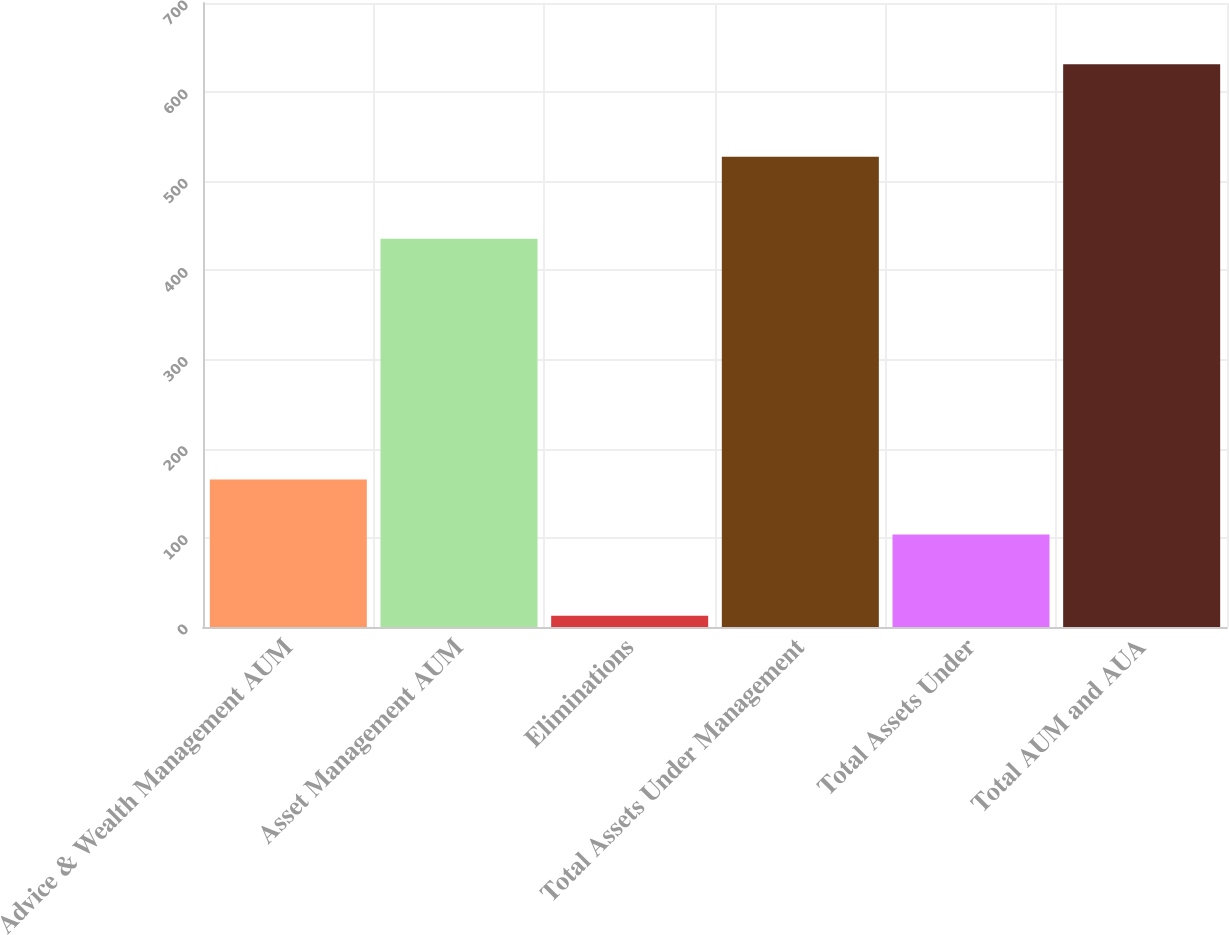Convert chart to OTSL. <chart><loc_0><loc_0><loc_500><loc_500><bar_chart><fcel>Advice & Wealth Management AUM<fcel>Asset Management AUM<fcel>Eliminations<fcel>Total Assets Under Management<fcel>Total Assets Under<fcel>Total AUM and AUA<nl><fcel>165.57<fcel>435.5<fcel>12.6<fcel>527.6<fcel>103.7<fcel>631.3<nl></chart> 